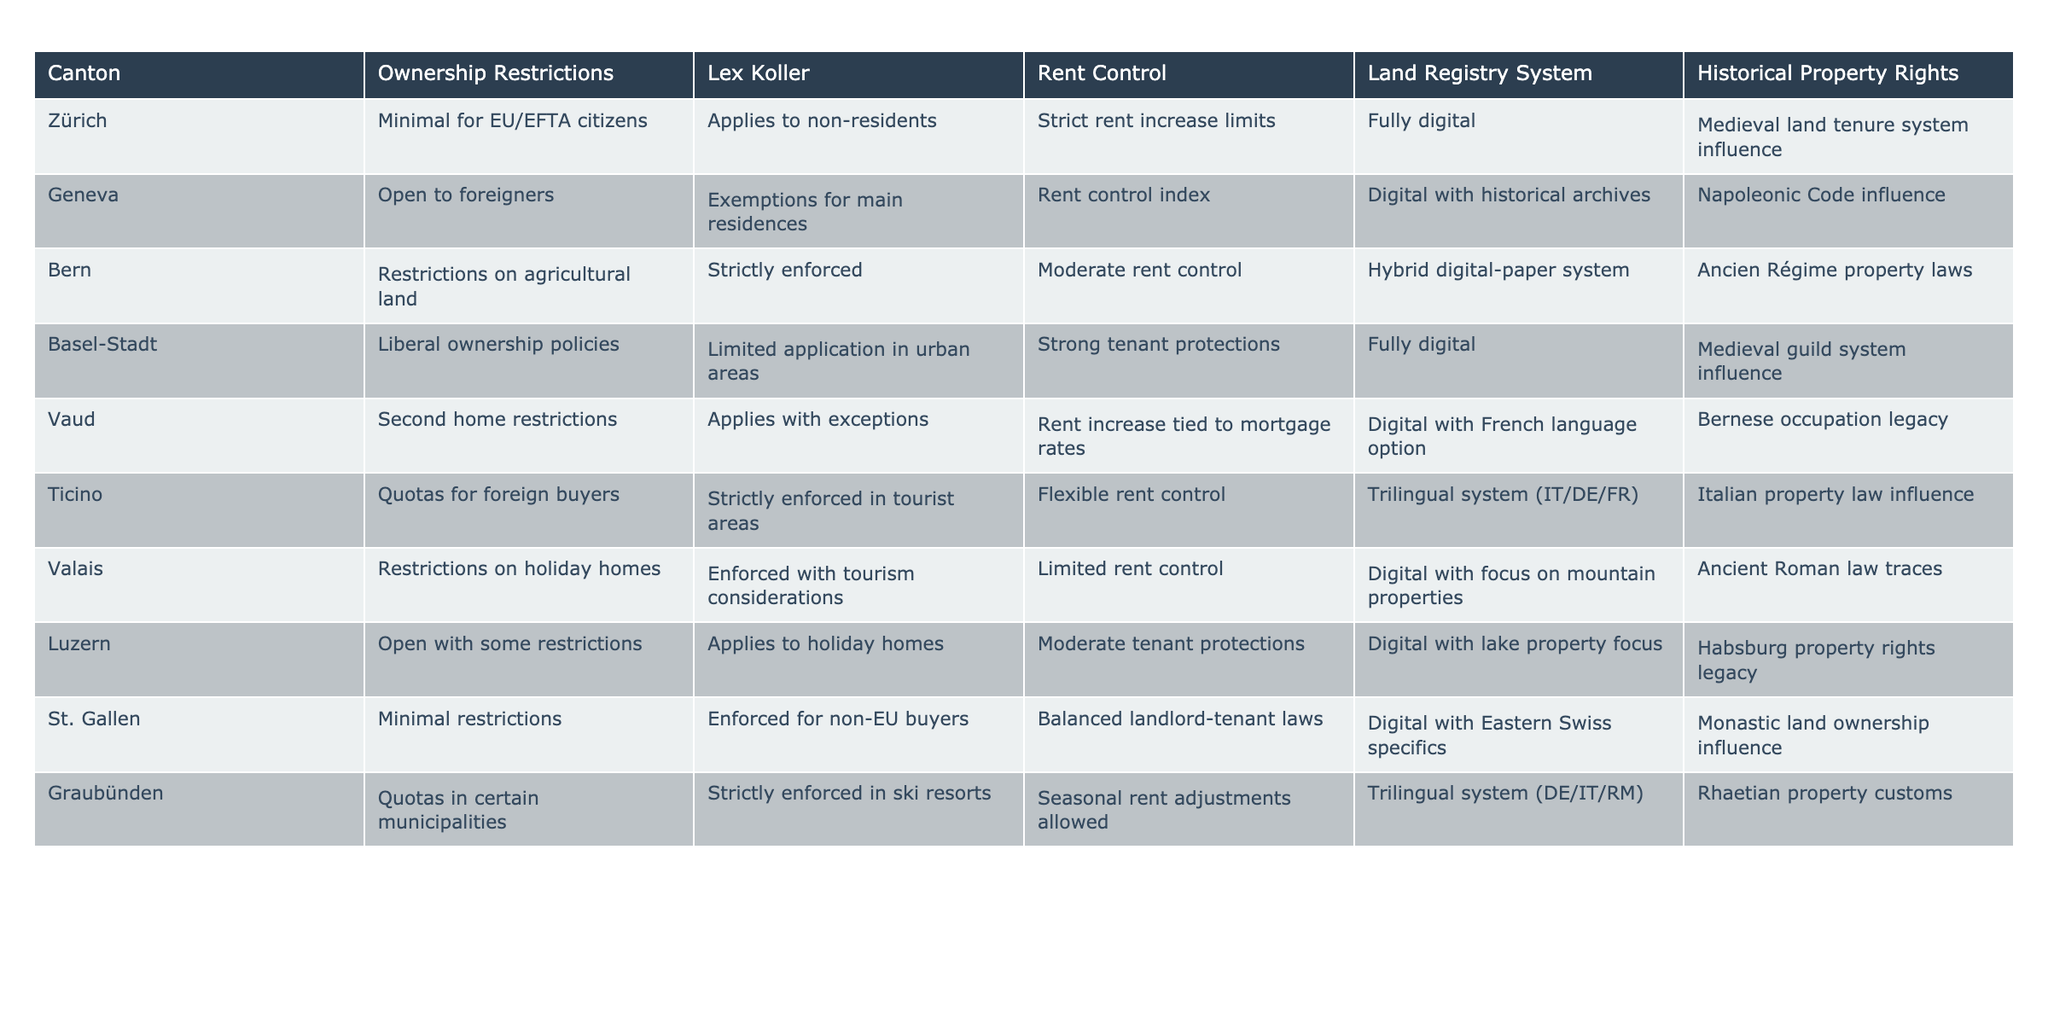What are the ownership restrictions in Zürich? The table indicates that there are minimal ownership restrictions for EU/EFTA citizens in Zürich. This means that these individuals face few hurdles when purchasing property in the canton.
Answer: Minimal for EU/EFTA citizens Is rent control implemented in Geneva? According to the table, Geneva has a rent control index, which suggests that there are mechanisms in place to regulate rent prices in this canton.
Answer: Yes, rent control index Which canton has a hybrid digital-paper land registry system? The table shows that Bern possesses a hybrid system for land registration, meaning it incorporates both digital and traditional paper records for property transactions.
Answer: Bern Are there any restrictions for foreign buyers in Ticino? The table indicates that Ticino has quotas for foreign buyers, meaning there are limitations on the number of properties that can be bought by non-residents in this area.
Answer: Yes, quotas for foreign buyers What influence does the medieval guild system have on Basel-Stadt's property rights? The table states that the medieval guild system influences property rights in Basel-Stadt. This suggests historical regulations or customs in property ownership trace back to guild systems that existed in medieval times.
Answer: Medieval guild system influence What is the average level of rent control in the cantons listed? To find the average level of rent control, we can assign numerical values to the degree of rent control: Strict (3), Moderate (2), Limited (1), and Flexible (0). We count the entries: 4 Strict, 3 Moderate, 2 Limited, and 1 Flexible. Thus, (4*3 + 3*2 + 2*1 + 1*0) / 10 = (12 + 6 + 2 + 0) / 10 = 20 / 10 = 2. The average level of rent control across the cantons is Moderate.
Answer: Moderate Does Luzern have an entirely open ownership policy? The table notes that Luzern has open ownership policies but mentions certain restrictions, which indicates that not all property purchases are entirely unrestricted.
Answer: No, some restrictions apply In which canton is the influence of the Napoleonic Code seen? The table specifies that Geneva's historical property rights are influenced by the Napoleonic Code, indicating a linkage to the principles established during the Napoleonic era affecting property law in this canton.
Answer: Geneva How does the land registry system in Vaud differ from the one in Zürich? The table reveals that Vaud's land registry is digital with a French language option, while Zürich's system is fully digital. The difference lies in the language option offered in Vaud's system.
Answer: Vaud offers French language option; Zürich is fully digital 